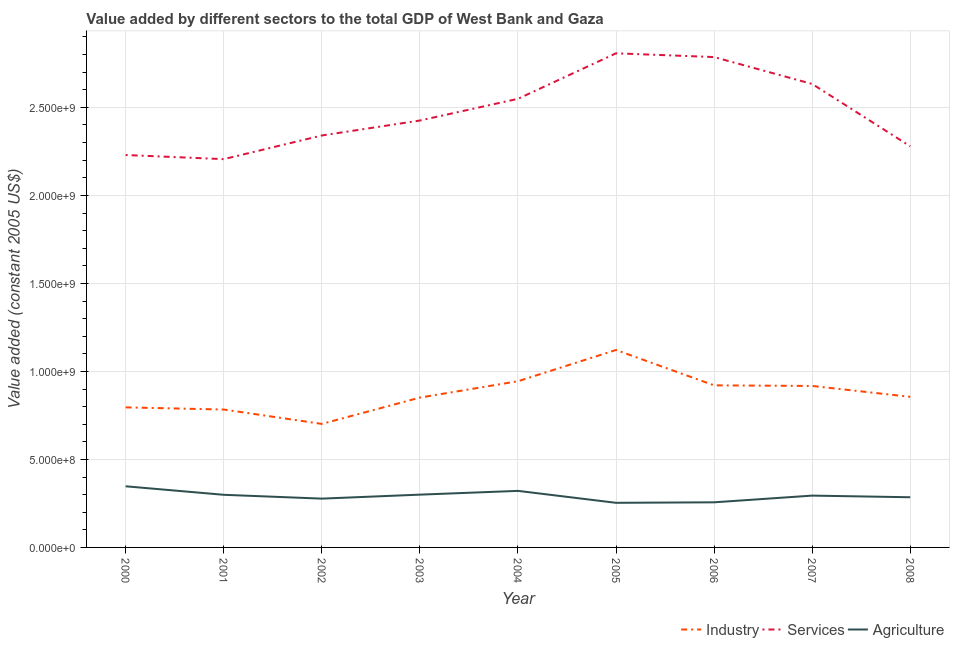How many different coloured lines are there?
Offer a very short reply. 3. Does the line corresponding to value added by services intersect with the line corresponding to value added by industrial sector?
Offer a very short reply. No. What is the value added by services in 2004?
Offer a very short reply. 2.55e+09. Across all years, what is the maximum value added by services?
Your response must be concise. 2.81e+09. Across all years, what is the minimum value added by agricultural sector?
Keep it short and to the point. 2.53e+08. In which year was the value added by industrial sector maximum?
Your response must be concise. 2005. What is the total value added by industrial sector in the graph?
Provide a succinct answer. 7.89e+09. What is the difference between the value added by industrial sector in 2004 and that in 2005?
Provide a succinct answer. -1.77e+08. What is the difference between the value added by agricultural sector in 2006 and the value added by services in 2003?
Ensure brevity in your answer.  -2.17e+09. What is the average value added by industrial sector per year?
Provide a succinct answer. 8.77e+08. In the year 2006, what is the difference between the value added by agricultural sector and value added by services?
Offer a very short reply. -2.53e+09. What is the ratio of the value added by agricultural sector in 2000 to that in 2007?
Ensure brevity in your answer.  1.18. What is the difference between the highest and the second highest value added by services?
Offer a very short reply. 2.14e+07. What is the difference between the highest and the lowest value added by services?
Give a very brief answer. 6.01e+08. In how many years, is the value added by agricultural sector greater than the average value added by agricultural sector taken over all years?
Make the answer very short. 5. Is the sum of the value added by industrial sector in 2001 and 2008 greater than the maximum value added by agricultural sector across all years?
Ensure brevity in your answer.  Yes. Does the value added by services monotonically increase over the years?
Provide a short and direct response. No. Is the value added by industrial sector strictly greater than the value added by services over the years?
Offer a very short reply. No. How many lines are there?
Your response must be concise. 3. How many years are there in the graph?
Your answer should be compact. 9. What is the difference between two consecutive major ticks on the Y-axis?
Offer a very short reply. 5.00e+08. Does the graph contain any zero values?
Offer a terse response. No. How are the legend labels stacked?
Provide a succinct answer. Horizontal. What is the title of the graph?
Your response must be concise. Value added by different sectors to the total GDP of West Bank and Gaza. Does "Infant(male)" appear as one of the legend labels in the graph?
Your answer should be compact. No. What is the label or title of the X-axis?
Keep it short and to the point. Year. What is the label or title of the Y-axis?
Your answer should be compact. Value added (constant 2005 US$). What is the Value added (constant 2005 US$) in Industry in 2000?
Your answer should be very brief. 7.96e+08. What is the Value added (constant 2005 US$) of Services in 2000?
Ensure brevity in your answer.  2.23e+09. What is the Value added (constant 2005 US$) in Agriculture in 2000?
Offer a terse response. 3.47e+08. What is the Value added (constant 2005 US$) in Industry in 2001?
Your answer should be compact. 7.83e+08. What is the Value added (constant 2005 US$) of Services in 2001?
Provide a short and direct response. 2.21e+09. What is the Value added (constant 2005 US$) in Agriculture in 2001?
Offer a terse response. 2.99e+08. What is the Value added (constant 2005 US$) of Industry in 2002?
Offer a very short reply. 7.02e+08. What is the Value added (constant 2005 US$) of Services in 2002?
Provide a short and direct response. 2.34e+09. What is the Value added (constant 2005 US$) in Agriculture in 2002?
Your answer should be compact. 2.77e+08. What is the Value added (constant 2005 US$) of Industry in 2003?
Your answer should be compact. 8.51e+08. What is the Value added (constant 2005 US$) in Services in 2003?
Your response must be concise. 2.43e+09. What is the Value added (constant 2005 US$) in Agriculture in 2003?
Give a very brief answer. 3.00e+08. What is the Value added (constant 2005 US$) in Industry in 2004?
Ensure brevity in your answer.  9.44e+08. What is the Value added (constant 2005 US$) of Services in 2004?
Provide a succinct answer. 2.55e+09. What is the Value added (constant 2005 US$) of Agriculture in 2004?
Provide a short and direct response. 3.21e+08. What is the Value added (constant 2005 US$) in Industry in 2005?
Provide a short and direct response. 1.12e+09. What is the Value added (constant 2005 US$) in Services in 2005?
Give a very brief answer. 2.81e+09. What is the Value added (constant 2005 US$) in Agriculture in 2005?
Keep it short and to the point. 2.53e+08. What is the Value added (constant 2005 US$) of Industry in 2006?
Your response must be concise. 9.21e+08. What is the Value added (constant 2005 US$) of Services in 2006?
Your answer should be very brief. 2.79e+09. What is the Value added (constant 2005 US$) in Agriculture in 2006?
Ensure brevity in your answer.  2.56e+08. What is the Value added (constant 2005 US$) in Industry in 2007?
Your response must be concise. 9.17e+08. What is the Value added (constant 2005 US$) of Services in 2007?
Provide a succinct answer. 2.63e+09. What is the Value added (constant 2005 US$) of Agriculture in 2007?
Give a very brief answer. 2.94e+08. What is the Value added (constant 2005 US$) of Industry in 2008?
Provide a succinct answer. 8.56e+08. What is the Value added (constant 2005 US$) of Services in 2008?
Offer a very short reply. 2.28e+09. What is the Value added (constant 2005 US$) of Agriculture in 2008?
Give a very brief answer. 2.85e+08. Across all years, what is the maximum Value added (constant 2005 US$) of Industry?
Provide a short and direct response. 1.12e+09. Across all years, what is the maximum Value added (constant 2005 US$) of Services?
Ensure brevity in your answer.  2.81e+09. Across all years, what is the maximum Value added (constant 2005 US$) in Agriculture?
Keep it short and to the point. 3.47e+08. Across all years, what is the minimum Value added (constant 2005 US$) in Industry?
Provide a succinct answer. 7.02e+08. Across all years, what is the minimum Value added (constant 2005 US$) of Services?
Your answer should be very brief. 2.21e+09. Across all years, what is the minimum Value added (constant 2005 US$) of Agriculture?
Provide a short and direct response. 2.53e+08. What is the total Value added (constant 2005 US$) in Industry in the graph?
Provide a short and direct response. 7.89e+09. What is the total Value added (constant 2005 US$) of Services in the graph?
Offer a very short reply. 2.23e+1. What is the total Value added (constant 2005 US$) of Agriculture in the graph?
Give a very brief answer. 2.63e+09. What is the difference between the Value added (constant 2005 US$) of Industry in 2000 and that in 2001?
Give a very brief answer. 1.23e+07. What is the difference between the Value added (constant 2005 US$) in Services in 2000 and that in 2001?
Your answer should be very brief. 2.35e+07. What is the difference between the Value added (constant 2005 US$) in Agriculture in 2000 and that in 2001?
Make the answer very short. 4.83e+07. What is the difference between the Value added (constant 2005 US$) of Industry in 2000 and that in 2002?
Provide a short and direct response. 9.39e+07. What is the difference between the Value added (constant 2005 US$) in Services in 2000 and that in 2002?
Ensure brevity in your answer.  -1.11e+08. What is the difference between the Value added (constant 2005 US$) in Agriculture in 2000 and that in 2002?
Make the answer very short. 7.00e+07. What is the difference between the Value added (constant 2005 US$) of Industry in 2000 and that in 2003?
Your answer should be compact. -5.56e+07. What is the difference between the Value added (constant 2005 US$) in Services in 2000 and that in 2003?
Offer a terse response. -1.96e+08. What is the difference between the Value added (constant 2005 US$) in Agriculture in 2000 and that in 2003?
Offer a very short reply. 4.75e+07. What is the difference between the Value added (constant 2005 US$) in Industry in 2000 and that in 2004?
Ensure brevity in your answer.  -1.49e+08. What is the difference between the Value added (constant 2005 US$) in Services in 2000 and that in 2004?
Your answer should be very brief. -3.19e+08. What is the difference between the Value added (constant 2005 US$) of Agriculture in 2000 and that in 2004?
Your response must be concise. 2.60e+07. What is the difference between the Value added (constant 2005 US$) of Industry in 2000 and that in 2005?
Keep it short and to the point. -3.26e+08. What is the difference between the Value added (constant 2005 US$) of Services in 2000 and that in 2005?
Ensure brevity in your answer.  -5.78e+08. What is the difference between the Value added (constant 2005 US$) in Agriculture in 2000 and that in 2005?
Your answer should be very brief. 9.39e+07. What is the difference between the Value added (constant 2005 US$) of Industry in 2000 and that in 2006?
Your answer should be compact. -1.25e+08. What is the difference between the Value added (constant 2005 US$) in Services in 2000 and that in 2006?
Your answer should be very brief. -5.56e+08. What is the difference between the Value added (constant 2005 US$) in Agriculture in 2000 and that in 2006?
Your response must be concise. 9.10e+07. What is the difference between the Value added (constant 2005 US$) of Industry in 2000 and that in 2007?
Your response must be concise. -1.22e+08. What is the difference between the Value added (constant 2005 US$) in Services in 2000 and that in 2007?
Give a very brief answer. -4.04e+08. What is the difference between the Value added (constant 2005 US$) of Agriculture in 2000 and that in 2007?
Provide a short and direct response. 5.30e+07. What is the difference between the Value added (constant 2005 US$) in Industry in 2000 and that in 2008?
Ensure brevity in your answer.  -5.98e+07. What is the difference between the Value added (constant 2005 US$) of Services in 2000 and that in 2008?
Make the answer very short. -4.95e+07. What is the difference between the Value added (constant 2005 US$) in Agriculture in 2000 and that in 2008?
Give a very brief answer. 6.22e+07. What is the difference between the Value added (constant 2005 US$) in Industry in 2001 and that in 2002?
Provide a short and direct response. 8.16e+07. What is the difference between the Value added (constant 2005 US$) in Services in 2001 and that in 2002?
Your answer should be compact. -1.34e+08. What is the difference between the Value added (constant 2005 US$) of Agriculture in 2001 and that in 2002?
Provide a short and direct response. 2.17e+07. What is the difference between the Value added (constant 2005 US$) in Industry in 2001 and that in 2003?
Provide a short and direct response. -6.78e+07. What is the difference between the Value added (constant 2005 US$) of Services in 2001 and that in 2003?
Keep it short and to the point. -2.20e+08. What is the difference between the Value added (constant 2005 US$) of Agriculture in 2001 and that in 2003?
Offer a terse response. -8.63e+05. What is the difference between the Value added (constant 2005 US$) of Industry in 2001 and that in 2004?
Your response must be concise. -1.61e+08. What is the difference between the Value added (constant 2005 US$) of Services in 2001 and that in 2004?
Ensure brevity in your answer.  -3.43e+08. What is the difference between the Value added (constant 2005 US$) in Agriculture in 2001 and that in 2004?
Your answer should be compact. -2.23e+07. What is the difference between the Value added (constant 2005 US$) of Industry in 2001 and that in 2005?
Offer a terse response. -3.38e+08. What is the difference between the Value added (constant 2005 US$) of Services in 2001 and that in 2005?
Give a very brief answer. -6.01e+08. What is the difference between the Value added (constant 2005 US$) in Agriculture in 2001 and that in 2005?
Your response must be concise. 4.56e+07. What is the difference between the Value added (constant 2005 US$) in Industry in 2001 and that in 2006?
Offer a very short reply. -1.37e+08. What is the difference between the Value added (constant 2005 US$) of Services in 2001 and that in 2006?
Offer a terse response. -5.80e+08. What is the difference between the Value added (constant 2005 US$) in Agriculture in 2001 and that in 2006?
Your answer should be compact. 4.27e+07. What is the difference between the Value added (constant 2005 US$) of Industry in 2001 and that in 2007?
Keep it short and to the point. -1.34e+08. What is the difference between the Value added (constant 2005 US$) of Services in 2001 and that in 2007?
Provide a succinct answer. -4.27e+08. What is the difference between the Value added (constant 2005 US$) in Agriculture in 2001 and that in 2007?
Your response must be concise. 4.65e+06. What is the difference between the Value added (constant 2005 US$) of Industry in 2001 and that in 2008?
Provide a short and direct response. -7.21e+07. What is the difference between the Value added (constant 2005 US$) in Services in 2001 and that in 2008?
Provide a succinct answer. -7.29e+07. What is the difference between the Value added (constant 2005 US$) in Agriculture in 2001 and that in 2008?
Ensure brevity in your answer.  1.39e+07. What is the difference between the Value added (constant 2005 US$) of Industry in 2002 and that in 2003?
Provide a succinct answer. -1.49e+08. What is the difference between the Value added (constant 2005 US$) of Services in 2002 and that in 2003?
Give a very brief answer. -8.51e+07. What is the difference between the Value added (constant 2005 US$) of Agriculture in 2002 and that in 2003?
Keep it short and to the point. -2.26e+07. What is the difference between the Value added (constant 2005 US$) in Industry in 2002 and that in 2004?
Keep it short and to the point. -2.42e+08. What is the difference between the Value added (constant 2005 US$) of Services in 2002 and that in 2004?
Your answer should be very brief. -2.08e+08. What is the difference between the Value added (constant 2005 US$) of Agriculture in 2002 and that in 2004?
Offer a very short reply. -4.40e+07. What is the difference between the Value added (constant 2005 US$) of Industry in 2002 and that in 2005?
Make the answer very short. -4.20e+08. What is the difference between the Value added (constant 2005 US$) in Services in 2002 and that in 2005?
Ensure brevity in your answer.  -4.67e+08. What is the difference between the Value added (constant 2005 US$) in Agriculture in 2002 and that in 2005?
Your answer should be compact. 2.39e+07. What is the difference between the Value added (constant 2005 US$) of Industry in 2002 and that in 2006?
Keep it short and to the point. -2.19e+08. What is the difference between the Value added (constant 2005 US$) in Services in 2002 and that in 2006?
Provide a succinct answer. -4.46e+08. What is the difference between the Value added (constant 2005 US$) of Agriculture in 2002 and that in 2006?
Keep it short and to the point. 2.10e+07. What is the difference between the Value added (constant 2005 US$) of Industry in 2002 and that in 2007?
Keep it short and to the point. -2.16e+08. What is the difference between the Value added (constant 2005 US$) in Services in 2002 and that in 2007?
Your answer should be very brief. -2.93e+08. What is the difference between the Value added (constant 2005 US$) of Agriculture in 2002 and that in 2007?
Keep it short and to the point. -1.71e+07. What is the difference between the Value added (constant 2005 US$) of Industry in 2002 and that in 2008?
Offer a terse response. -1.54e+08. What is the difference between the Value added (constant 2005 US$) of Services in 2002 and that in 2008?
Make the answer very short. 6.14e+07. What is the difference between the Value added (constant 2005 US$) in Agriculture in 2002 and that in 2008?
Provide a short and direct response. -7.83e+06. What is the difference between the Value added (constant 2005 US$) of Industry in 2003 and that in 2004?
Your answer should be very brief. -9.30e+07. What is the difference between the Value added (constant 2005 US$) in Services in 2003 and that in 2004?
Ensure brevity in your answer.  -1.23e+08. What is the difference between the Value added (constant 2005 US$) of Agriculture in 2003 and that in 2004?
Give a very brief answer. -2.14e+07. What is the difference between the Value added (constant 2005 US$) in Industry in 2003 and that in 2005?
Provide a short and direct response. -2.70e+08. What is the difference between the Value added (constant 2005 US$) in Services in 2003 and that in 2005?
Offer a very short reply. -3.82e+08. What is the difference between the Value added (constant 2005 US$) in Agriculture in 2003 and that in 2005?
Ensure brevity in your answer.  4.65e+07. What is the difference between the Value added (constant 2005 US$) in Industry in 2003 and that in 2006?
Keep it short and to the point. -6.95e+07. What is the difference between the Value added (constant 2005 US$) of Services in 2003 and that in 2006?
Offer a terse response. -3.60e+08. What is the difference between the Value added (constant 2005 US$) of Agriculture in 2003 and that in 2006?
Give a very brief answer. 4.36e+07. What is the difference between the Value added (constant 2005 US$) in Industry in 2003 and that in 2007?
Keep it short and to the point. -6.61e+07. What is the difference between the Value added (constant 2005 US$) of Services in 2003 and that in 2007?
Give a very brief answer. -2.08e+08. What is the difference between the Value added (constant 2005 US$) of Agriculture in 2003 and that in 2007?
Your answer should be compact. 5.51e+06. What is the difference between the Value added (constant 2005 US$) in Industry in 2003 and that in 2008?
Ensure brevity in your answer.  -4.26e+06. What is the difference between the Value added (constant 2005 US$) in Services in 2003 and that in 2008?
Offer a terse response. 1.47e+08. What is the difference between the Value added (constant 2005 US$) in Agriculture in 2003 and that in 2008?
Keep it short and to the point. 1.48e+07. What is the difference between the Value added (constant 2005 US$) of Industry in 2004 and that in 2005?
Ensure brevity in your answer.  -1.77e+08. What is the difference between the Value added (constant 2005 US$) of Services in 2004 and that in 2005?
Ensure brevity in your answer.  -2.59e+08. What is the difference between the Value added (constant 2005 US$) in Agriculture in 2004 and that in 2005?
Provide a short and direct response. 6.79e+07. What is the difference between the Value added (constant 2005 US$) in Industry in 2004 and that in 2006?
Your answer should be very brief. 2.35e+07. What is the difference between the Value added (constant 2005 US$) of Services in 2004 and that in 2006?
Your answer should be very brief. -2.37e+08. What is the difference between the Value added (constant 2005 US$) in Agriculture in 2004 and that in 2006?
Your answer should be very brief. 6.50e+07. What is the difference between the Value added (constant 2005 US$) of Industry in 2004 and that in 2007?
Provide a short and direct response. 2.69e+07. What is the difference between the Value added (constant 2005 US$) of Services in 2004 and that in 2007?
Your answer should be compact. -8.44e+07. What is the difference between the Value added (constant 2005 US$) in Agriculture in 2004 and that in 2007?
Your answer should be compact. 2.69e+07. What is the difference between the Value added (constant 2005 US$) in Industry in 2004 and that in 2008?
Offer a very short reply. 8.87e+07. What is the difference between the Value added (constant 2005 US$) in Services in 2004 and that in 2008?
Your answer should be very brief. 2.70e+08. What is the difference between the Value added (constant 2005 US$) in Agriculture in 2004 and that in 2008?
Offer a very short reply. 3.62e+07. What is the difference between the Value added (constant 2005 US$) of Industry in 2005 and that in 2006?
Your response must be concise. 2.01e+08. What is the difference between the Value added (constant 2005 US$) of Services in 2005 and that in 2006?
Your response must be concise. 2.14e+07. What is the difference between the Value added (constant 2005 US$) of Agriculture in 2005 and that in 2006?
Your answer should be very brief. -2.89e+06. What is the difference between the Value added (constant 2005 US$) of Industry in 2005 and that in 2007?
Offer a very short reply. 2.04e+08. What is the difference between the Value added (constant 2005 US$) of Services in 2005 and that in 2007?
Keep it short and to the point. 1.74e+08. What is the difference between the Value added (constant 2005 US$) in Agriculture in 2005 and that in 2007?
Offer a very short reply. -4.09e+07. What is the difference between the Value added (constant 2005 US$) of Industry in 2005 and that in 2008?
Your answer should be compact. 2.66e+08. What is the difference between the Value added (constant 2005 US$) of Services in 2005 and that in 2008?
Your answer should be compact. 5.28e+08. What is the difference between the Value added (constant 2005 US$) in Agriculture in 2005 and that in 2008?
Your response must be concise. -3.17e+07. What is the difference between the Value added (constant 2005 US$) in Industry in 2006 and that in 2007?
Your answer should be compact. 3.44e+06. What is the difference between the Value added (constant 2005 US$) in Services in 2006 and that in 2007?
Offer a very short reply. 1.53e+08. What is the difference between the Value added (constant 2005 US$) in Agriculture in 2006 and that in 2007?
Keep it short and to the point. -3.81e+07. What is the difference between the Value added (constant 2005 US$) in Industry in 2006 and that in 2008?
Provide a succinct answer. 6.53e+07. What is the difference between the Value added (constant 2005 US$) of Services in 2006 and that in 2008?
Keep it short and to the point. 5.07e+08. What is the difference between the Value added (constant 2005 US$) in Agriculture in 2006 and that in 2008?
Your answer should be very brief. -2.88e+07. What is the difference between the Value added (constant 2005 US$) of Industry in 2007 and that in 2008?
Provide a succinct answer. 6.18e+07. What is the difference between the Value added (constant 2005 US$) of Services in 2007 and that in 2008?
Your answer should be compact. 3.54e+08. What is the difference between the Value added (constant 2005 US$) of Agriculture in 2007 and that in 2008?
Your response must be concise. 9.26e+06. What is the difference between the Value added (constant 2005 US$) of Industry in 2000 and the Value added (constant 2005 US$) of Services in 2001?
Provide a short and direct response. -1.41e+09. What is the difference between the Value added (constant 2005 US$) in Industry in 2000 and the Value added (constant 2005 US$) in Agriculture in 2001?
Offer a very short reply. 4.97e+08. What is the difference between the Value added (constant 2005 US$) in Services in 2000 and the Value added (constant 2005 US$) in Agriculture in 2001?
Provide a succinct answer. 1.93e+09. What is the difference between the Value added (constant 2005 US$) in Industry in 2000 and the Value added (constant 2005 US$) in Services in 2002?
Give a very brief answer. -1.54e+09. What is the difference between the Value added (constant 2005 US$) in Industry in 2000 and the Value added (constant 2005 US$) in Agriculture in 2002?
Make the answer very short. 5.18e+08. What is the difference between the Value added (constant 2005 US$) in Services in 2000 and the Value added (constant 2005 US$) in Agriculture in 2002?
Provide a short and direct response. 1.95e+09. What is the difference between the Value added (constant 2005 US$) of Industry in 2000 and the Value added (constant 2005 US$) of Services in 2003?
Make the answer very short. -1.63e+09. What is the difference between the Value added (constant 2005 US$) in Industry in 2000 and the Value added (constant 2005 US$) in Agriculture in 2003?
Offer a terse response. 4.96e+08. What is the difference between the Value added (constant 2005 US$) in Services in 2000 and the Value added (constant 2005 US$) in Agriculture in 2003?
Make the answer very short. 1.93e+09. What is the difference between the Value added (constant 2005 US$) of Industry in 2000 and the Value added (constant 2005 US$) of Services in 2004?
Make the answer very short. -1.75e+09. What is the difference between the Value added (constant 2005 US$) in Industry in 2000 and the Value added (constant 2005 US$) in Agriculture in 2004?
Ensure brevity in your answer.  4.74e+08. What is the difference between the Value added (constant 2005 US$) of Services in 2000 and the Value added (constant 2005 US$) of Agriculture in 2004?
Ensure brevity in your answer.  1.91e+09. What is the difference between the Value added (constant 2005 US$) in Industry in 2000 and the Value added (constant 2005 US$) in Services in 2005?
Provide a succinct answer. -2.01e+09. What is the difference between the Value added (constant 2005 US$) in Industry in 2000 and the Value added (constant 2005 US$) in Agriculture in 2005?
Offer a terse response. 5.42e+08. What is the difference between the Value added (constant 2005 US$) in Services in 2000 and the Value added (constant 2005 US$) in Agriculture in 2005?
Give a very brief answer. 1.98e+09. What is the difference between the Value added (constant 2005 US$) in Industry in 2000 and the Value added (constant 2005 US$) in Services in 2006?
Offer a terse response. -1.99e+09. What is the difference between the Value added (constant 2005 US$) in Industry in 2000 and the Value added (constant 2005 US$) in Agriculture in 2006?
Your answer should be compact. 5.39e+08. What is the difference between the Value added (constant 2005 US$) in Services in 2000 and the Value added (constant 2005 US$) in Agriculture in 2006?
Offer a very short reply. 1.97e+09. What is the difference between the Value added (constant 2005 US$) in Industry in 2000 and the Value added (constant 2005 US$) in Services in 2007?
Offer a terse response. -1.84e+09. What is the difference between the Value added (constant 2005 US$) in Industry in 2000 and the Value added (constant 2005 US$) in Agriculture in 2007?
Your answer should be compact. 5.01e+08. What is the difference between the Value added (constant 2005 US$) of Services in 2000 and the Value added (constant 2005 US$) of Agriculture in 2007?
Make the answer very short. 1.94e+09. What is the difference between the Value added (constant 2005 US$) in Industry in 2000 and the Value added (constant 2005 US$) in Services in 2008?
Make the answer very short. -1.48e+09. What is the difference between the Value added (constant 2005 US$) of Industry in 2000 and the Value added (constant 2005 US$) of Agriculture in 2008?
Make the answer very short. 5.11e+08. What is the difference between the Value added (constant 2005 US$) of Services in 2000 and the Value added (constant 2005 US$) of Agriculture in 2008?
Offer a terse response. 1.94e+09. What is the difference between the Value added (constant 2005 US$) in Industry in 2001 and the Value added (constant 2005 US$) in Services in 2002?
Provide a short and direct response. -1.56e+09. What is the difference between the Value added (constant 2005 US$) of Industry in 2001 and the Value added (constant 2005 US$) of Agriculture in 2002?
Make the answer very short. 5.06e+08. What is the difference between the Value added (constant 2005 US$) in Services in 2001 and the Value added (constant 2005 US$) in Agriculture in 2002?
Provide a succinct answer. 1.93e+09. What is the difference between the Value added (constant 2005 US$) of Industry in 2001 and the Value added (constant 2005 US$) of Services in 2003?
Your response must be concise. -1.64e+09. What is the difference between the Value added (constant 2005 US$) in Industry in 2001 and the Value added (constant 2005 US$) in Agriculture in 2003?
Offer a terse response. 4.84e+08. What is the difference between the Value added (constant 2005 US$) in Services in 2001 and the Value added (constant 2005 US$) in Agriculture in 2003?
Provide a succinct answer. 1.91e+09. What is the difference between the Value added (constant 2005 US$) of Industry in 2001 and the Value added (constant 2005 US$) of Services in 2004?
Keep it short and to the point. -1.77e+09. What is the difference between the Value added (constant 2005 US$) of Industry in 2001 and the Value added (constant 2005 US$) of Agriculture in 2004?
Your answer should be very brief. 4.62e+08. What is the difference between the Value added (constant 2005 US$) of Services in 2001 and the Value added (constant 2005 US$) of Agriculture in 2004?
Your answer should be compact. 1.88e+09. What is the difference between the Value added (constant 2005 US$) of Industry in 2001 and the Value added (constant 2005 US$) of Services in 2005?
Ensure brevity in your answer.  -2.02e+09. What is the difference between the Value added (constant 2005 US$) of Industry in 2001 and the Value added (constant 2005 US$) of Agriculture in 2005?
Offer a terse response. 5.30e+08. What is the difference between the Value added (constant 2005 US$) in Services in 2001 and the Value added (constant 2005 US$) in Agriculture in 2005?
Provide a short and direct response. 1.95e+09. What is the difference between the Value added (constant 2005 US$) in Industry in 2001 and the Value added (constant 2005 US$) in Services in 2006?
Provide a succinct answer. -2.00e+09. What is the difference between the Value added (constant 2005 US$) of Industry in 2001 and the Value added (constant 2005 US$) of Agriculture in 2006?
Ensure brevity in your answer.  5.27e+08. What is the difference between the Value added (constant 2005 US$) of Services in 2001 and the Value added (constant 2005 US$) of Agriculture in 2006?
Your response must be concise. 1.95e+09. What is the difference between the Value added (constant 2005 US$) in Industry in 2001 and the Value added (constant 2005 US$) in Services in 2007?
Give a very brief answer. -1.85e+09. What is the difference between the Value added (constant 2005 US$) in Industry in 2001 and the Value added (constant 2005 US$) in Agriculture in 2007?
Offer a terse response. 4.89e+08. What is the difference between the Value added (constant 2005 US$) of Services in 2001 and the Value added (constant 2005 US$) of Agriculture in 2007?
Offer a very short reply. 1.91e+09. What is the difference between the Value added (constant 2005 US$) of Industry in 2001 and the Value added (constant 2005 US$) of Services in 2008?
Keep it short and to the point. -1.50e+09. What is the difference between the Value added (constant 2005 US$) in Industry in 2001 and the Value added (constant 2005 US$) in Agriculture in 2008?
Offer a terse response. 4.98e+08. What is the difference between the Value added (constant 2005 US$) of Services in 2001 and the Value added (constant 2005 US$) of Agriculture in 2008?
Make the answer very short. 1.92e+09. What is the difference between the Value added (constant 2005 US$) in Industry in 2002 and the Value added (constant 2005 US$) in Services in 2003?
Ensure brevity in your answer.  -1.72e+09. What is the difference between the Value added (constant 2005 US$) of Industry in 2002 and the Value added (constant 2005 US$) of Agriculture in 2003?
Your response must be concise. 4.02e+08. What is the difference between the Value added (constant 2005 US$) of Services in 2002 and the Value added (constant 2005 US$) of Agriculture in 2003?
Provide a succinct answer. 2.04e+09. What is the difference between the Value added (constant 2005 US$) of Industry in 2002 and the Value added (constant 2005 US$) of Services in 2004?
Your answer should be very brief. -1.85e+09. What is the difference between the Value added (constant 2005 US$) in Industry in 2002 and the Value added (constant 2005 US$) in Agriculture in 2004?
Give a very brief answer. 3.81e+08. What is the difference between the Value added (constant 2005 US$) of Services in 2002 and the Value added (constant 2005 US$) of Agriculture in 2004?
Offer a terse response. 2.02e+09. What is the difference between the Value added (constant 2005 US$) of Industry in 2002 and the Value added (constant 2005 US$) of Services in 2005?
Keep it short and to the point. -2.11e+09. What is the difference between the Value added (constant 2005 US$) in Industry in 2002 and the Value added (constant 2005 US$) in Agriculture in 2005?
Give a very brief answer. 4.48e+08. What is the difference between the Value added (constant 2005 US$) of Services in 2002 and the Value added (constant 2005 US$) of Agriculture in 2005?
Your answer should be compact. 2.09e+09. What is the difference between the Value added (constant 2005 US$) in Industry in 2002 and the Value added (constant 2005 US$) in Services in 2006?
Your answer should be compact. -2.08e+09. What is the difference between the Value added (constant 2005 US$) of Industry in 2002 and the Value added (constant 2005 US$) of Agriculture in 2006?
Your response must be concise. 4.46e+08. What is the difference between the Value added (constant 2005 US$) in Services in 2002 and the Value added (constant 2005 US$) in Agriculture in 2006?
Provide a succinct answer. 2.08e+09. What is the difference between the Value added (constant 2005 US$) of Industry in 2002 and the Value added (constant 2005 US$) of Services in 2007?
Offer a terse response. -1.93e+09. What is the difference between the Value added (constant 2005 US$) of Industry in 2002 and the Value added (constant 2005 US$) of Agriculture in 2007?
Give a very brief answer. 4.07e+08. What is the difference between the Value added (constant 2005 US$) of Services in 2002 and the Value added (constant 2005 US$) of Agriculture in 2007?
Offer a very short reply. 2.05e+09. What is the difference between the Value added (constant 2005 US$) of Industry in 2002 and the Value added (constant 2005 US$) of Services in 2008?
Provide a short and direct response. -1.58e+09. What is the difference between the Value added (constant 2005 US$) in Industry in 2002 and the Value added (constant 2005 US$) in Agriculture in 2008?
Ensure brevity in your answer.  4.17e+08. What is the difference between the Value added (constant 2005 US$) of Services in 2002 and the Value added (constant 2005 US$) of Agriculture in 2008?
Make the answer very short. 2.06e+09. What is the difference between the Value added (constant 2005 US$) of Industry in 2003 and the Value added (constant 2005 US$) of Services in 2004?
Give a very brief answer. -1.70e+09. What is the difference between the Value added (constant 2005 US$) in Industry in 2003 and the Value added (constant 2005 US$) in Agriculture in 2004?
Make the answer very short. 5.30e+08. What is the difference between the Value added (constant 2005 US$) in Services in 2003 and the Value added (constant 2005 US$) in Agriculture in 2004?
Provide a succinct answer. 2.10e+09. What is the difference between the Value added (constant 2005 US$) of Industry in 2003 and the Value added (constant 2005 US$) of Services in 2005?
Your answer should be very brief. -1.96e+09. What is the difference between the Value added (constant 2005 US$) of Industry in 2003 and the Value added (constant 2005 US$) of Agriculture in 2005?
Provide a succinct answer. 5.98e+08. What is the difference between the Value added (constant 2005 US$) of Services in 2003 and the Value added (constant 2005 US$) of Agriculture in 2005?
Make the answer very short. 2.17e+09. What is the difference between the Value added (constant 2005 US$) of Industry in 2003 and the Value added (constant 2005 US$) of Services in 2006?
Ensure brevity in your answer.  -1.93e+09. What is the difference between the Value added (constant 2005 US$) of Industry in 2003 and the Value added (constant 2005 US$) of Agriculture in 2006?
Make the answer very short. 5.95e+08. What is the difference between the Value added (constant 2005 US$) in Services in 2003 and the Value added (constant 2005 US$) in Agriculture in 2006?
Ensure brevity in your answer.  2.17e+09. What is the difference between the Value added (constant 2005 US$) of Industry in 2003 and the Value added (constant 2005 US$) of Services in 2007?
Provide a short and direct response. -1.78e+09. What is the difference between the Value added (constant 2005 US$) of Industry in 2003 and the Value added (constant 2005 US$) of Agriculture in 2007?
Make the answer very short. 5.57e+08. What is the difference between the Value added (constant 2005 US$) of Services in 2003 and the Value added (constant 2005 US$) of Agriculture in 2007?
Your response must be concise. 2.13e+09. What is the difference between the Value added (constant 2005 US$) of Industry in 2003 and the Value added (constant 2005 US$) of Services in 2008?
Give a very brief answer. -1.43e+09. What is the difference between the Value added (constant 2005 US$) of Industry in 2003 and the Value added (constant 2005 US$) of Agriculture in 2008?
Give a very brief answer. 5.66e+08. What is the difference between the Value added (constant 2005 US$) of Services in 2003 and the Value added (constant 2005 US$) of Agriculture in 2008?
Make the answer very short. 2.14e+09. What is the difference between the Value added (constant 2005 US$) in Industry in 2004 and the Value added (constant 2005 US$) in Services in 2005?
Provide a short and direct response. -1.86e+09. What is the difference between the Value added (constant 2005 US$) in Industry in 2004 and the Value added (constant 2005 US$) in Agriculture in 2005?
Give a very brief answer. 6.91e+08. What is the difference between the Value added (constant 2005 US$) of Services in 2004 and the Value added (constant 2005 US$) of Agriculture in 2005?
Give a very brief answer. 2.30e+09. What is the difference between the Value added (constant 2005 US$) in Industry in 2004 and the Value added (constant 2005 US$) in Services in 2006?
Make the answer very short. -1.84e+09. What is the difference between the Value added (constant 2005 US$) of Industry in 2004 and the Value added (constant 2005 US$) of Agriculture in 2006?
Keep it short and to the point. 6.88e+08. What is the difference between the Value added (constant 2005 US$) of Services in 2004 and the Value added (constant 2005 US$) of Agriculture in 2006?
Your answer should be compact. 2.29e+09. What is the difference between the Value added (constant 2005 US$) in Industry in 2004 and the Value added (constant 2005 US$) in Services in 2007?
Provide a short and direct response. -1.69e+09. What is the difference between the Value added (constant 2005 US$) in Industry in 2004 and the Value added (constant 2005 US$) in Agriculture in 2007?
Your response must be concise. 6.50e+08. What is the difference between the Value added (constant 2005 US$) in Services in 2004 and the Value added (constant 2005 US$) in Agriculture in 2007?
Make the answer very short. 2.25e+09. What is the difference between the Value added (constant 2005 US$) in Industry in 2004 and the Value added (constant 2005 US$) in Services in 2008?
Your answer should be compact. -1.33e+09. What is the difference between the Value added (constant 2005 US$) in Industry in 2004 and the Value added (constant 2005 US$) in Agriculture in 2008?
Your response must be concise. 6.59e+08. What is the difference between the Value added (constant 2005 US$) in Services in 2004 and the Value added (constant 2005 US$) in Agriculture in 2008?
Provide a short and direct response. 2.26e+09. What is the difference between the Value added (constant 2005 US$) of Industry in 2005 and the Value added (constant 2005 US$) of Services in 2006?
Provide a short and direct response. -1.66e+09. What is the difference between the Value added (constant 2005 US$) in Industry in 2005 and the Value added (constant 2005 US$) in Agriculture in 2006?
Provide a succinct answer. 8.65e+08. What is the difference between the Value added (constant 2005 US$) of Services in 2005 and the Value added (constant 2005 US$) of Agriculture in 2006?
Offer a very short reply. 2.55e+09. What is the difference between the Value added (constant 2005 US$) in Industry in 2005 and the Value added (constant 2005 US$) in Services in 2007?
Provide a succinct answer. -1.51e+09. What is the difference between the Value added (constant 2005 US$) in Industry in 2005 and the Value added (constant 2005 US$) in Agriculture in 2007?
Ensure brevity in your answer.  8.27e+08. What is the difference between the Value added (constant 2005 US$) in Services in 2005 and the Value added (constant 2005 US$) in Agriculture in 2007?
Keep it short and to the point. 2.51e+09. What is the difference between the Value added (constant 2005 US$) in Industry in 2005 and the Value added (constant 2005 US$) in Services in 2008?
Your answer should be compact. -1.16e+09. What is the difference between the Value added (constant 2005 US$) in Industry in 2005 and the Value added (constant 2005 US$) in Agriculture in 2008?
Keep it short and to the point. 8.37e+08. What is the difference between the Value added (constant 2005 US$) of Services in 2005 and the Value added (constant 2005 US$) of Agriculture in 2008?
Provide a succinct answer. 2.52e+09. What is the difference between the Value added (constant 2005 US$) of Industry in 2006 and the Value added (constant 2005 US$) of Services in 2007?
Offer a terse response. -1.71e+09. What is the difference between the Value added (constant 2005 US$) in Industry in 2006 and the Value added (constant 2005 US$) in Agriculture in 2007?
Your answer should be compact. 6.26e+08. What is the difference between the Value added (constant 2005 US$) in Services in 2006 and the Value added (constant 2005 US$) in Agriculture in 2007?
Provide a short and direct response. 2.49e+09. What is the difference between the Value added (constant 2005 US$) of Industry in 2006 and the Value added (constant 2005 US$) of Services in 2008?
Your response must be concise. -1.36e+09. What is the difference between the Value added (constant 2005 US$) in Industry in 2006 and the Value added (constant 2005 US$) in Agriculture in 2008?
Your response must be concise. 6.36e+08. What is the difference between the Value added (constant 2005 US$) of Services in 2006 and the Value added (constant 2005 US$) of Agriculture in 2008?
Your answer should be very brief. 2.50e+09. What is the difference between the Value added (constant 2005 US$) in Industry in 2007 and the Value added (constant 2005 US$) in Services in 2008?
Provide a short and direct response. -1.36e+09. What is the difference between the Value added (constant 2005 US$) in Industry in 2007 and the Value added (constant 2005 US$) in Agriculture in 2008?
Your response must be concise. 6.32e+08. What is the difference between the Value added (constant 2005 US$) in Services in 2007 and the Value added (constant 2005 US$) in Agriculture in 2008?
Provide a short and direct response. 2.35e+09. What is the average Value added (constant 2005 US$) of Industry per year?
Your answer should be very brief. 8.77e+08. What is the average Value added (constant 2005 US$) in Services per year?
Offer a terse response. 2.47e+09. What is the average Value added (constant 2005 US$) in Agriculture per year?
Ensure brevity in your answer.  2.93e+08. In the year 2000, what is the difference between the Value added (constant 2005 US$) of Industry and Value added (constant 2005 US$) of Services?
Make the answer very short. -1.43e+09. In the year 2000, what is the difference between the Value added (constant 2005 US$) of Industry and Value added (constant 2005 US$) of Agriculture?
Your answer should be very brief. 4.48e+08. In the year 2000, what is the difference between the Value added (constant 2005 US$) in Services and Value added (constant 2005 US$) in Agriculture?
Offer a very short reply. 1.88e+09. In the year 2001, what is the difference between the Value added (constant 2005 US$) of Industry and Value added (constant 2005 US$) of Services?
Make the answer very short. -1.42e+09. In the year 2001, what is the difference between the Value added (constant 2005 US$) of Industry and Value added (constant 2005 US$) of Agriculture?
Offer a very short reply. 4.84e+08. In the year 2001, what is the difference between the Value added (constant 2005 US$) in Services and Value added (constant 2005 US$) in Agriculture?
Provide a short and direct response. 1.91e+09. In the year 2002, what is the difference between the Value added (constant 2005 US$) of Industry and Value added (constant 2005 US$) of Services?
Keep it short and to the point. -1.64e+09. In the year 2002, what is the difference between the Value added (constant 2005 US$) in Industry and Value added (constant 2005 US$) in Agriculture?
Offer a terse response. 4.25e+08. In the year 2002, what is the difference between the Value added (constant 2005 US$) in Services and Value added (constant 2005 US$) in Agriculture?
Make the answer very short. 2.06e+09. In the year 2003, what is the difference between the Value added (constant 2005 US$) in Industry and Value added (constant 2005 US$) in Services?
Make the answer very short. -1.57e+09. In the year 2003, what is the difference between the Value added (constant 2005 US$) of Industry and Value added (constant 2005 US$) of Agriculture?
Keep it short and to the point. 5.51e+08. In the year 2003, what is the difference between the Value added (constant 2005 US$) of Services and Value added (constant 2005 US$) of Agriculture?
Ensure brevity in your answer.  2.13e+09. In the year 2004, what is the difference between the Value added (constant 2005 US$) in Industry and Value added (constant 2005 US$) in Services?
Your answer should be very brief. -1.60e+09. In the year 2004, what is the difference between the Value added (constant 2005 US$) in Industry and Value added (constant 2005 US$) in Agriculture?
Make the answer very short. 6.23e+08. In the year 2004, what is the difference between the Value added (constant 2005 US$) of Services and Value added (constant 2005 US$) of Agriculture?
Your response must be concise. 2.23e+09. In the year 2005, what is the difference between the Value added (constant 2005 US$) in Industry and Value added (constant 2005 US$) in Services?
Ensure brevity in your answer.  -1.69e+09. In the year 2005, what is the difference between the Value added (constant 2005 US$) in Industry and Value added (constant 2005 US$) in Agriculture?
Your answer should be compact. 8.68e+08. In the year 2005, what is the difference between the Value added (constant 2005 US$) in Services and Value added (constant 2005 US$) in Agriculture?
Offer a very short reply. 2.55e+09. In the year 2006, what is the difference between the Value added (constant 2005 US$) of Industry and Value added (constant 2005 US$) of Services?
Your answer should be very brief. -1.87e+09. In the year 2006, what is the difference between the Value added (constant 2005 US$) in Industry and Value added (constant 2005 US$) in Agriculture?
Keep it short and to the point. 6.65e+08. In the year 2006, what is the difference between the Value added (constant 2005 US$) in Services and Value added (constant 2005 US$) in Agriculture?
Give a very brief answer. 2.53e+09. In the year 2007, what is the difference between the Value added (constant 2005 US$) of Industry and Value added (constant 2005 US$) of Services?
Your answer should be compact. -1.72e+09. In the year 2007, what is the difference between the Value added (constant 2005 US$) of Industry and Value added (constant 2005 US$) of Agriculture?
Provide a short and direct response. 6.23e+08. In the year 2007, what is the difference between the Value added (constant 2005 US$) in Services and Value added (constant 2005 US$) in Agriculture?
Your answer should be compact. 2.34e+09. In the year 2008, what is the difference between the Value added (constant 2005 US$) in Industry and Value added (constant 2005 US$) in Services?
Keep it short and to the point. -1.42e+09. In the year 2008, what is the difference between the Value added (constant 2005 US$) of Industry and Value added (constant 2005 US$) of Agriculture?
Give a very brief answer. 5.70e+08. In the year 2008, what is the difference between the Value added (constant 2005 US$) in Services and Value added (constant 2005 US$) in Agriculture?
Your answer should be compact. 1.99e+09. What is the ratio of the Value added (constant 2005 US$) of Industry in 2000 to that in 2001?
Your answer should be very brief. 1.02. What is the ratio of the Value added (constant 2005 US$) of Services in 2000 to that in 2001?
Provide a short and direct response. 1.01. What is the ratio of the Value added (constant 2005 US$) of Agriculture in 2000 to that in 2001?
Provide a short and direct response. 1.16. What is the ratio of the Value added (constant 2005 US$) of Industry in 2000 to that in 2002?
Make the answer very short. 1.13. What is the ratio of the Value added (constant 2005 US$) in Services in 2000 to that in 2002?
Offer a very short reply. 0.95. What is the ratio of the Value added (constant 2005 US$) in Agriculture in 2000 to that in 2002?
Give a very brief answer. 1.25. What is the ratio of the Value added (constant 2005 US$) of Industry in 2000 to that in 2003?
Give a very brief answer. 0.93. What is the ratio of the Value added (constant 2005 US$) of Services in 2000 to that in 2003?
Your answer should be compact. 0.92. What is the ratio of the Value added (constant 2005 US$) of Agriculture in 2000 to that in 2003?
Your response must be concise. 1.16. What is the ratio of the Value added (constant 2005 US$) in Industry in 2000 to that in 2004?
Offer a terse response. 0.84. What is the ratio of the Value added (constant 2005 US$) of Services in 2000 to that in 2004?
Ensure brevity in your answer.  0.87. What is the ratio of the Value added (constant 2005 US$) in Agriculture in 2000 to that in 2004?
Provide a succinct answer. 1.08. What is the ratio of the Value added (constant 2005 US$) in Industry in 2000 to that in 2005?
Give a very brief answer. 0.71. What is the ratio of the Value added (constant 2005 US$) in Services in 2000 to that in 2005?
Give a very brief answer. 0.79. What is the ratio of the Value added (constant 2005 US$) of Agriculture in 2000 to that in 2005?
Your answer should be compact. 1.37. What is the ratio of the Value added (constant 2005 US$) of Industry in 2000 to that in 2006?
Your answer should be very brief. 0.86. What is the ratio of the Value added (constant 2005 US$) in Services in 2000 to that in 2006?
Offer a very short reply. 0.8. What is the ratio of the Value added (constant 2005 US$) of Agriculture in 2000 to that in 2006?
Offer a terse response. 1.36. What is the ratio of the Value added (constant 2005 US$) of Industry in 2000 to that in 2007?
Ensure brevity in your answer.  0.87. What is the ratio of the Value added (constant 2005 US$) of Services in 2000 to that in 2007?
Keep it short and to the point. 0.85. What is the ratio of the Value added (constant 2005 US$) in Agriculture in 2000 to that in 2007?
Make the answer very short. 1.18. What is the ratio of the Value added (constant 2005 US$) of Industry in 2000 to that in 2008?
Give a very brief answer. 0.93. What is the ratio of the Value added (constant 2005 US$) in Services in 2000 to that in 2008?
Provide a short and direct response. 0.98. What is the ratio of the Value added (constant 2005 US$) of Agriculture in 2000 to that in 2008?
Provide a succinct answer. 1.22. What is the ratio of the Value added (constant 2005 US$) in Industry in 2001 to that in 2002?
Ensure brevity in your answer.  1.12. What is the ratio of the Value added (constant 2005 US$) of Services in 2001 to that in 2002?
Provide a short and direct response. 0.94. What is the ratio of the Value added (constant 2005 US$) of Agriculture in 2001 to that in 2002?
Keep it short and to the point. 1.08. What is the ratio of the Value added (constant 2005 US$) in Industry in 2001 to that in 2003?
Ensure brevity in your answer.  0.92. What is the ratio of the Value added (constant 2005 US$) in Services in 2001 to that in 2003?
Provide a succinct answer. 0.91. What is the ratio of the Value added (constant 2005 US$) of Agriculture in 2001 to that in 2003?
Keep it short and to the point. 1. What is the ratio of the Value added (constant 2005 US$) in Industry in 2001 to that in 2004?
Provide a succinct answer. 0.83. What is the ratio of the Value added (constant 2005 US$) in Services in 2001 to that in 2004?
Provide a succinct answer. 0.87. What is the ratio of the Value added (constant 2005 US$) of Agriculture in 2001 to that in 2004?
Give a very brief answer. 0.93. What is the ratio of the Value added (constant 2005 US$) of Industry in 2001 to that in 2005?
Offer a terse response. 0.7. What is the ratio of the Value added (constant 2005 US$) in Services in 2001 to that in 2005?
Provide a succinct answer. 0.79. What is the ratio of the Value added (constant 2005 US$) of Agriculture in 2001 to that in 2005?
Ensure brevity in your answer.  1.18. What is the ratio of the Value added (constant 2005 US$) in Industry in 2001 to that in 2006?
Your response must be concise. 0.85. What is the ratio of the Value added (constant 2005 US$) in Services in 2001 to that in 2006?
Provide a short and direct response. 0.79. What is the ratio of the Value added (constant 2005 US$) of Agriculture in 2001 to that in 2006?
Your answer should be compact. 1.17. What is the ratio of the Value added (constant 2005 US$) in Industry in 2001 to that in 2007?
Offer a very short reply. 0.85. What is the ratio of the Value added (constant 2005 US$) in Services in 2001 to that in 2007?
Offer a very short reply. 0.84. What is the ratio of the Value added (constant 2005 US$) in Agriculture in 2001 to that in 2007?
Keep it short and to the point. 1.02. What is the ratio of the Value added (constant 2005 US$) of Industry in 2001 to that in 2008?
Offer a terse response. 0.92. What is the ratio of the Value added (constant 2005 US$) of Services in 2001 to that in 2008?
Your answer should be very brief. 0.97. What is the ratio of the Value added (constant 2005 US$) in Agriculture in 2001 to that in 2008?
Keep it short and to the point. 1.05. What is the ratio of the Value added (constant 2005 US$) of Industry in 2002 to that in 2003?
Ensure brevity in your answer.  0.82. What is the ratio of the Value added (constant 2005 US$) in Services in 2002 to that in 2003?
Your response must be concise. 0.96. What is the ratio of the Value added (constant 2005 US$) in Agriculture in 2002 to that in 2003?
Offer a terse response. 0.92. What is the ratio of the Value added (constant 2005 US$) in Industry in 2002 to that in 2004?
Offer a very short reply. 0.74. What is the ratio of the Value added (constant 2005 US$) of Services in 2002 to that in 2004?
Keep it short and to the point. 0.92. What is the ratio of the Value added (constant 2005 US$) in Agriculture in 2002 to that in 2004?
Your answer should be very brief. 0.86. What is the ratio of the Value added (constant 2005 US$) in Industry in 2002 to that in 2005?
Your answer should be compact. 0.63. What is the ratio of the Value added (constant 2005 US$) in Services in 2002 to that in 2005?
Provide a short and direct response. 0.83. What is the ratio of the Value added (constant 2005 US$) in Agriculture in 2002 to that in 2005?
Keep it short and to the point. 1.09. What is the ratio of the Value added (constant 2005 US$) of Industry in 2002 to that in 2006?
Your answer should be very brief. 0.76. What is the ratio of the Value added (constant 2005 US$) of Services in 2002 to that in 2006?
Offer a terse response. 0.84. What is the ratio of the Value added (constant 2005 US$) of Agriculture in 2002 to that in 2006?
Your answer should be very brief. 1.08. What is the ratio of the Value added (constant 2005 US$) in Industry in 2002 to that in 2007?
Provide a short and direct response. 0.77. What is the ratio of the Value added (constant 2005 US$) of Services in 2002 to that in 2007?
Give a very brief answer. 0.89. What is the ratio of the Value added (constant 2005 US$) of Agriculture in 2002 to that in 2007?
Your answer should be compact. 0.94. What is the ratio of the Value added (constant 2005 US$) of Industry in 2002 to that in 2008?
Provide a short and direct response. 0.82. What is the ratio of the Value added (constant 2005 US$) of Agriculture in 2002 to that in 2008?
Your answer should be compact. 0.97. What is the ratio of the Value added (constant 2005 US$) in Industry in 2003 to that in 2004?
Give a very brief answer. 0.9. What is the ratio of the Value added (constant 2005 US$) in Services in 2003 to that in 2004?
Keep it short and to the point. 0.95. What is the ratio of the Value added (constant 2005 US$) in Industry in 2003 to that in 2005?
Your response must be concise. 0.76. What is the ratio of the Value added (constant 2005 US$) of Services in 2003 to that in 2005?
Give a very brief answer. 0.86. What is the ratio of the Value added (constant 2005 US$) in Agriculture in 2003 to that in 2005?
Your response must be concise. 1.18. What is the ratio of the Value added (constant 2005 US$) of Industry in 2003 to that in 2006?
Your answer should be very brief. 0.92. What is the ratio of the Value added (constant 2005 US$) of Services in 2003 to that in 2006?
Offer a terse response. 0.87. What is the ratio of the Value added (constant 2005 US$) in Agriculture in 2003 to that in 2006?
Your response must be concise. 1.17. What is the ratio of the Value added (constant 2005 US$) of Industry in 2003 to that in 2007?
Provide a short and direct response. 0.93. What is the ratio of the Value added (constant 2005 US$) in Services in 2003 to that in 2007?
Make the answer very short. 0.92. What is the ratio of the Value added (constant 2005 US$) in Agriculture in 2003 to that in 2007?
Make the answer very short. 1.02. What is the ratio of the Value added (constant 2005 US$) of Industry in 2003 to that in 2008?
Keep it short and to the point. 0.99. What is the ratio of the Value added (constant 2005 US$) of Services in 2003 to that in 2008?
Provide a succinct answer. 1.06. What is the ratio of the Value added (constant 2005 US$) of Agriculture in 2003 to that in 2008?
Your response must be concise. 1.05. What is the ratio of the Value added (constant 2005 US$) in Industry in 2004 to that in 2005?
Keep it short and to the point. 0.84. What is the ratio of the Value added (constant 2005 US$) of Services in 2004 to that in 2005?
Your answer should be compact. 0.91. What is the ratio of the Value added (constant 2005 US$) in Agriculture in 2004 to that in 2005?
Your answer should be compact. 1.27. What is the ratio of the Value added (constant 2005 US$) in Industry in 2004 to that in 2006?
Your answer should be very brief. 1.03. What is the ratio of the Value added (constant 2005 US$) of Services in 2004 to that in 2006?
Provide a succinct answer. 0.91. What is the ratio of the Value added (constant 2005 US$) in Agriculture in 2004 to that in 2006?
Provide a succinct answer. 1.25. What is the ratio of the Value added (constant 2005 US$) in Industry in 2004 to that in 2007?
Your response must be concise. 1.03. What is the ratio of the Value added (constant 2005 US$) of Services in 2004 to that in 2007?
Your answer should be very brief. 0.97. What is the ratio of the Value added (constant 2005 US$) of Agriculture in 2004 to that in 2007?
Make the answer very short. 1.09. What is the ratio of the Value added (constant 2005 US$) of Industry in 2004 to that in 2008?
Ensure brevity in your answer.  1.1. What is the ratio of the Value added (constant 2005 US$) in Services in 2004 to that in 2008?
Provide a succinct answer. 1.12. What is the ratio of the Value added (constant 2005 US$) in Agriculture in 2004 to that in 2008?
Offer a very short reply. 1.13. What is the ratio of the Value added (constant 2005 US$) of Industry in 2005 to that in 2006?
Make the answer very short. 1.22. What is the ratio of the Value added (constant 2005 US$) of Services in 2005 to that in 2006?
Your answer should be compact. 1.01. What is the ratio of the Value added (constant 2005 US$) of Agriculture in 2005 to that in 2006?
Ensure brevity in your answer.  0.99. What is the ratio of the Value added (constant 2005 US$) of Industry in 2005 to that in 2007?
Provide a succinct answer. 1.22. What is the ratio of the Value added (constant 2005 US$) of Services in 2005 to that in 2007?
Provide a short and direct response. 1.07. What is the ratio of the Value added (constant 2005 US$) in Agriculture in 2005 to that in 2007?
Ensure brevity in your answer.  0.86. What is the ratio of the Value added (constant 2005 US$) of Industry in 2005 to that in 2008?
Make the answer very short. 1.31. What is the ratio of the Value added (constant 2005 US$) of Services in 2005 to that in 2008?
Offer a very short reply. 1.23. What is the ratio of the Value added (constant 2005 US$) of Industry in 2006 to that in 2007?
Your answer should be very brief. 1. What is the ratio of the Value added (constant 2005 US$) in Services in 2006 to that in 2007?
Provide a succinct answer. 1.06. What is the ratio of the Value added (constant 2005 US$) in Agriculture in 2006 to that in 2007?
Your response must be concise. 0.87. What is the ratio of the Value added (constant 2005 US$) in Industry in 2006 to that in 2008?
Your answer should be compact. 1.08. What is the ratio of the Value added (constant 2005 US$) in Services in 2006 to that in 2008?
Offer a very short reply. 1.22. What is the ratio of the Value added (constant 2005 US$) of Agriculture in 2006 to that in 2008?
Provide a succinct answer. 0.9. What is the ratio of the Value added (constant 2005 US$) of Industry in 2007 to that in 2008?
Offer a terse response. 1.07. What is the ratio of the Value added (constant 2005 US$) in Services in 2007 to that in 2008?
Ensure brevity in your answer.  1.16. What is the ratio of the Value added (constant 2005 US$) of Agriculture in 2007 to that in 2008?
Your answer should be compact. 1.03. What is the difference between the highest and the second highest Value added (constant 2005 US$) of Industry?
Provide a short and direct response. 1.77e+08. What is the difference between the highest and the second highest Value added (constant 2005 US$) of Services?
Ensure brevity in your answer.  2.14e+07. What is the difference between the highest and the second highest Value added (constant 2005 US$) in Agriculture?
Make the answer very short. 2.60e+07. What is the difference between the highest and the lowest Value added (constant 2005 US$) in Industry?
Keep it short and to the point. 4.20e+08. What is the difference between the highest and the lowest Value added (constant 2005 US$) of Services?
Provide a short and direct response. 6.01e+08. What is the difference between the highest and the lowest Value added (constant 2005 US$) of Agriculture?
Your answer should be very brief. 9.39e+07. 